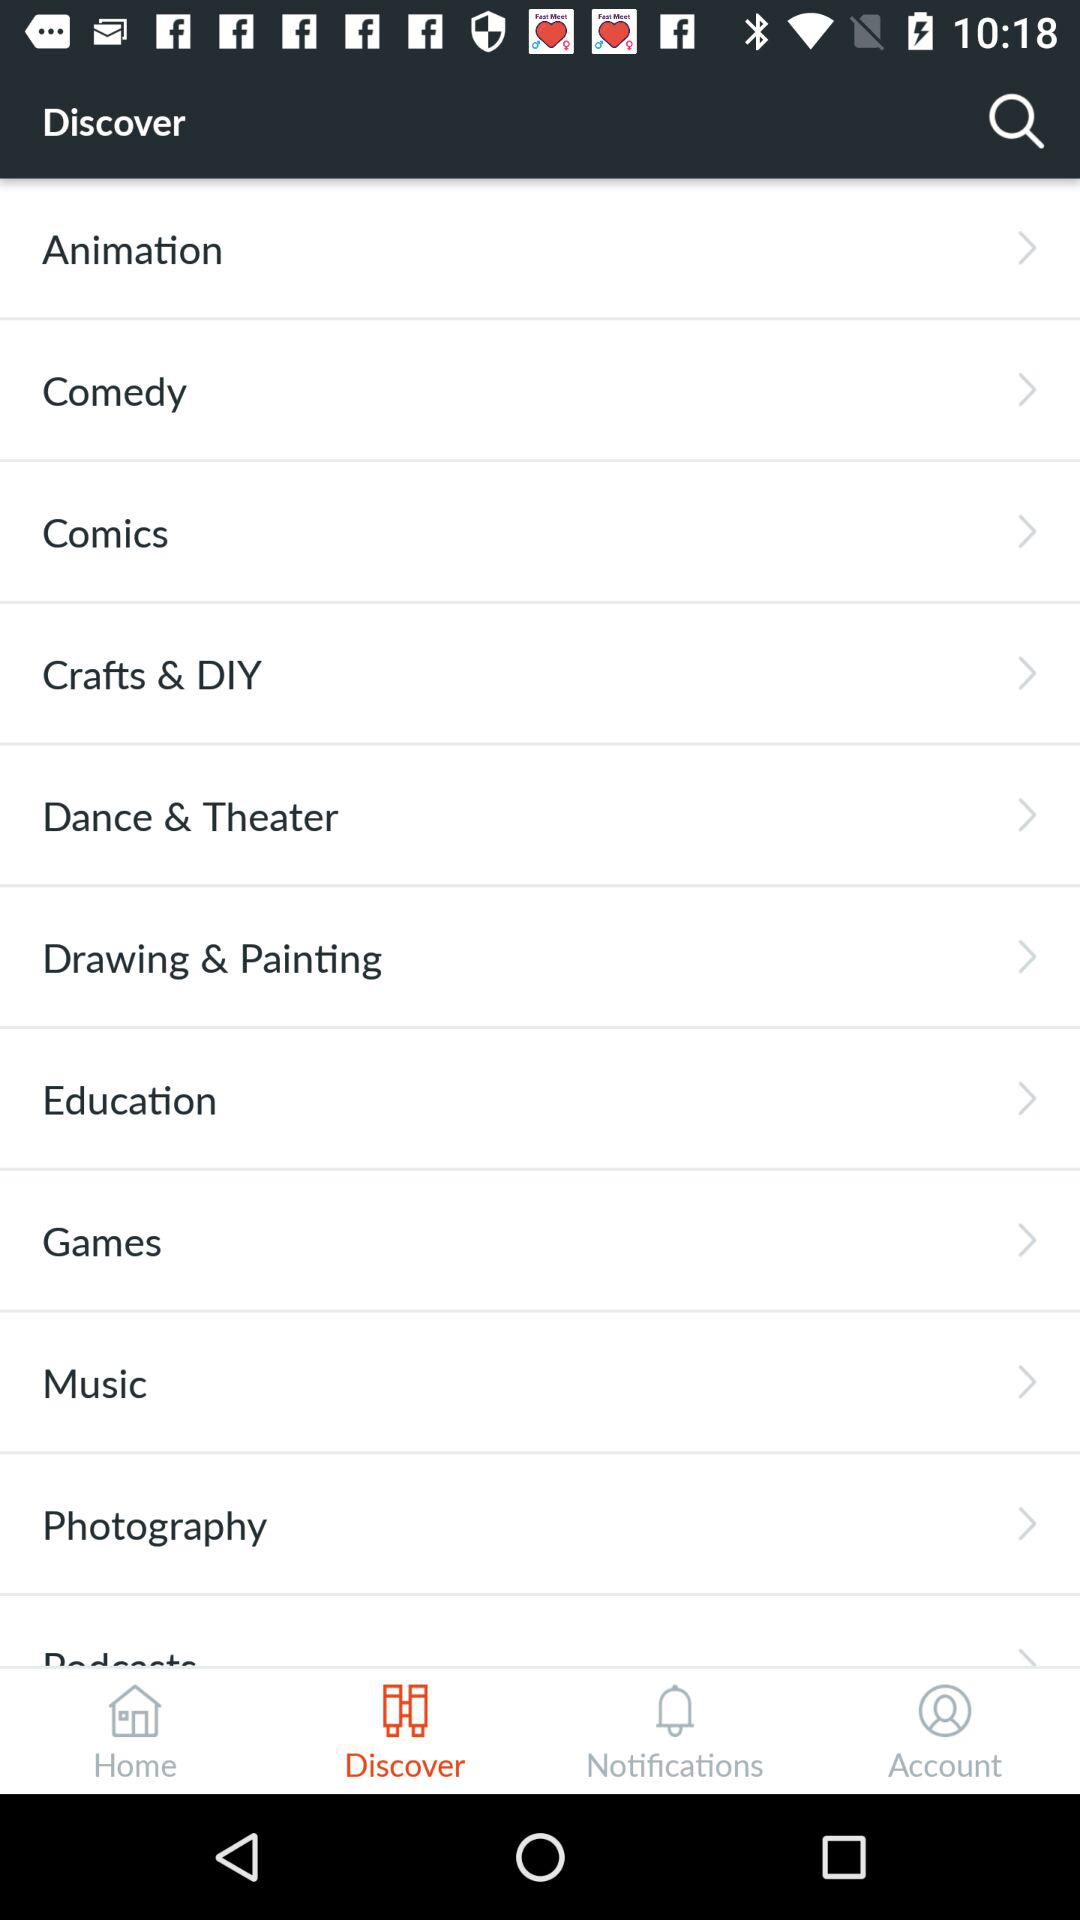Who is using the "Discover" search?
When the provided information is insufficient, respond with <no answer>. <no answer> 